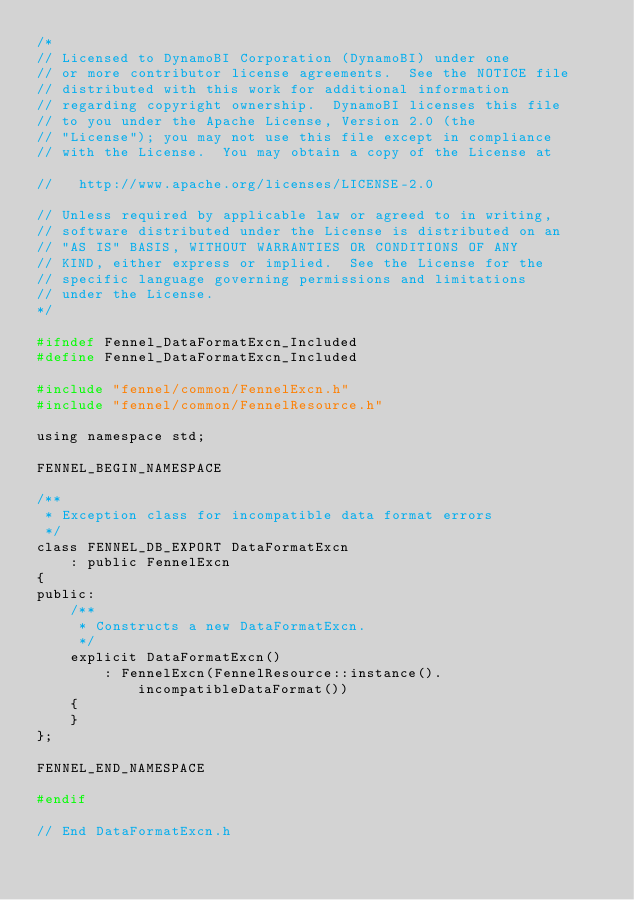<code> <loc_0><loc_0><loc_500><loc_500><_C_>/*
// Licensed to DynamoBI Corporation (DynamoBI) under one
// or more contributor license agreements.  See the NOTICE file
// distributed with this work for additional information
// regarding copyright ownership.  DynamoBI licenses this file
// to you under the Apache License, Version 2.0 (the
// "License"); you may not use this file except in compliance
// with the License.  You may obtain a copy of the License at

//   http://www.apache.org/licenses/LICENSE-2.0

// Unless required by applicable law or agreed to in writing,
// software distributed under the License is distributed on an
// "AS IS" BASIS, WITHOUT WARRANTIES OR CONDITIONS OF ANY
// KIND, either express or implied.  See the License for the
// specific language governing permissions and limitations
// under the License.
*/

#ifndef Fennel_DataFormatExcn_Included
#define Fennel_DataFormatExcn_Included

#include "fennel/common/FennelExcn.h"
#include "fennel/common/FennelResource.h"

using namespace std;

FENNEL_BEGIN_NAMESPACE

/**
 * Exception class for incompatible data format errors
 */
class FENNEL_DB_EXPORT DataFormatExcn
    : public FennelExcn
{
public:
    /**
     * Constructs a new DataFormatExcn.
     */
    explicit DataFormatExcn()
        : FennelExcn(FennelResource::instance().incompatibleDataFormat())
    {
    }
};

FENNEL_END_NAMESPACE

#endif

// End DataFormatExcn.h
</code> 